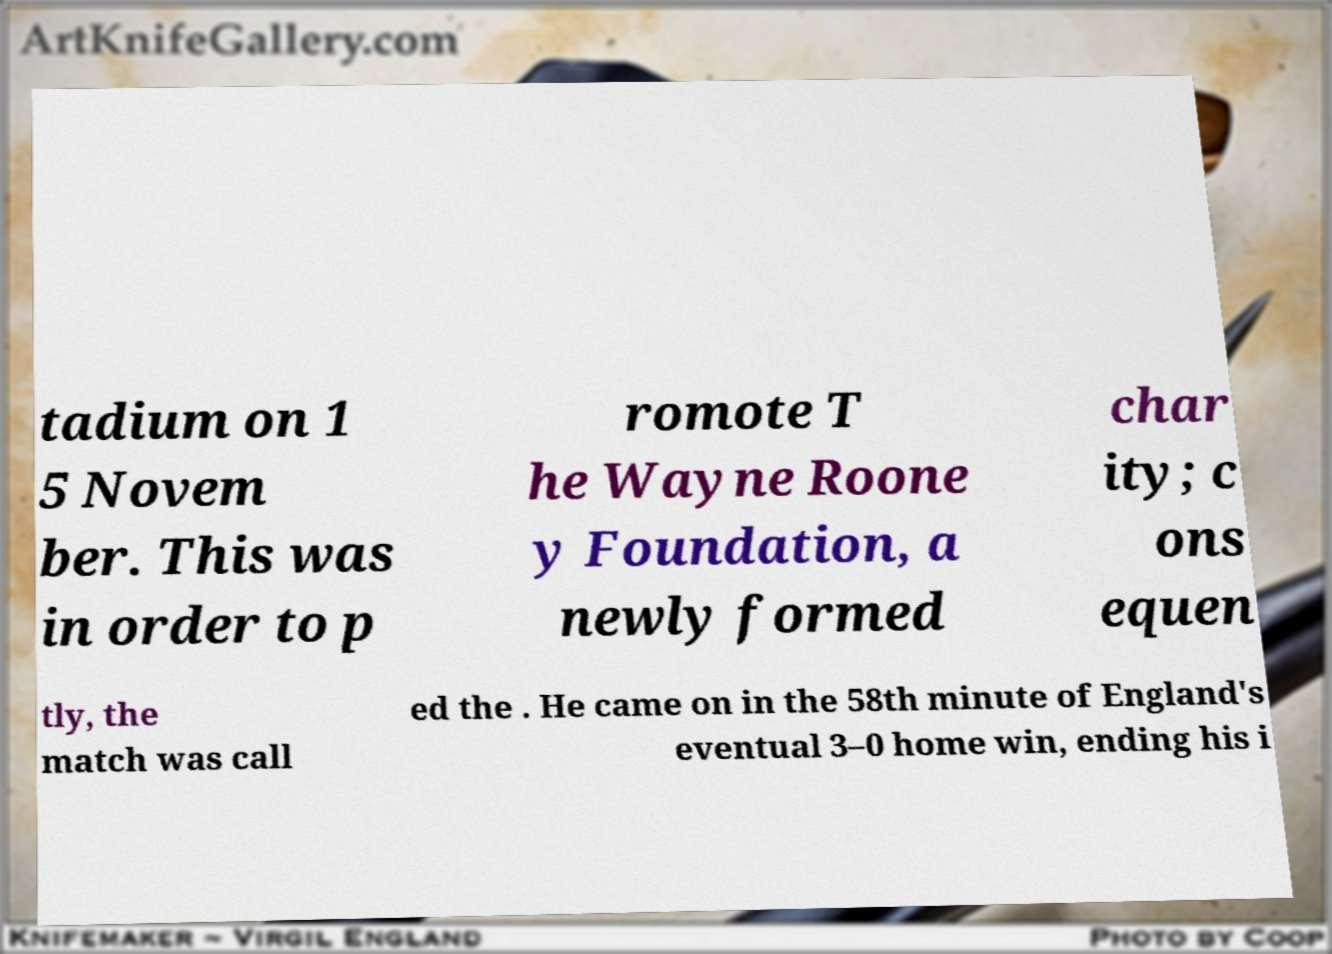Could you extract and type out the text from this image? tadium on 1 5 Novem ber. This was in order to p romote T he Wayne Roone y Foundation, a newly formed char ity; c ons equen tly, the match was call ed the . He came on in the 58th minute of England's eventual 3–0 home win, ending his i 